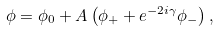Convert formula to latex. <formula><loc_0><loc_0><loc_500><loc_500>\phi = \phi _ { 0 } + A \left ( \phi _ { + } + e ^ { - 2 i \gamma } \phi _ { - } \right ) ,</formula> 